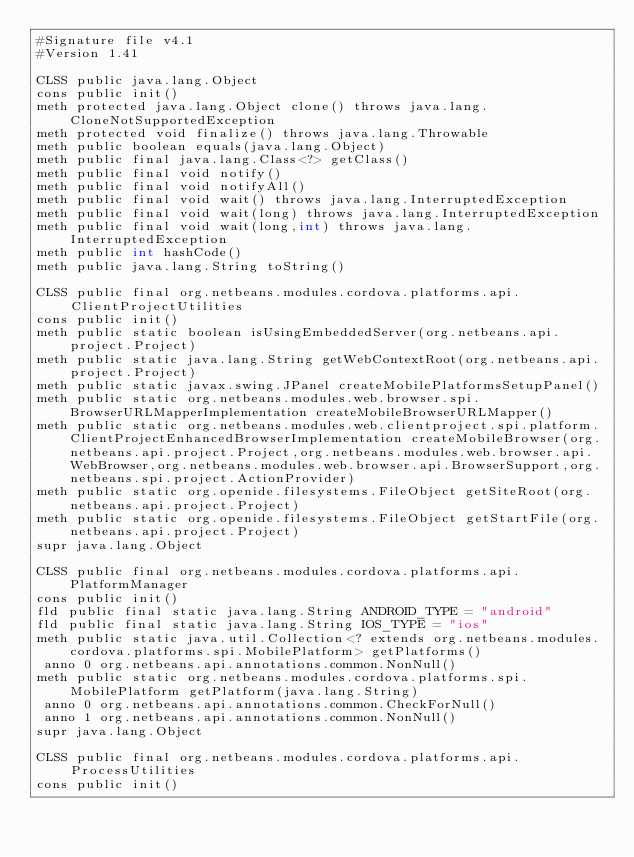Convert code to text. <code><loc_0><loc_0><loc_500><loc_500><_SML_>#Signature file v4.1
#Version 1.41

CLSS public java.lang.Object
cons public init()
meth protected java.lang.Object clone() throws java.lang.CloneNotSupportedException
meth protected void finalize() throws java.lang.Throwable
meth public boolean equals(java.lang.Object)
meth public final java.lang.Class<?> getClass()
meth public final void notify()
meth public final void notifyAll()
meth public final void wait() throws java.lang.InterruptedException
meth public final void wait(long) throws java.lang.InterruptedException
meth public final void wait(long,int) throws java.lang.InterruptedException
meth public int hashCode()
meth public java.lang.String toString()

CLSS public final org.netbeans.modules.cordova.platforms.api.ClientProjectUtilities
cons public init()
meth public static boolean isUsingEmbeddedServer(org.netbeans.api.project.Project)
meth public static java.lang.String getWebContextRoot(org.netbeans.api.project.Project)
meth public static javax.swing.JPanel createMobilePlatformsSetupPanel()
meth public static org.netbeans.modules.web.browser.spi.BrowserURLMapperImplementation createMobileBrowserURLMapper()
meth public static org.netbeans.modules.web.clientproject.spi.platform.ClientProjectEnhancedBrowserImplementation createMobileBrowser(org.netbeans.api.project.Project,org.netbeans.modules.web.browser.api.WebBrowser,org.netbeans.modules.web.browser.api.BrowserSupport,org.netbeans.spi.project.ActionProvider)
meth public static org.openide.filesystems.FileObject getSiteRoot(org.netbeans.api.project.Project)
meth public static org.openide.filesystems.FileObject getStartFile(org.netbeans.api.project.Project)
supr java.lang.Object

CLSS public final org.netbeans.modules.cordova.platforms.api.PlatformManager
cons public init()
fld public final static java.lang.String ANDROID_TYPE = "android"
fld public final static java.lang.String IOS_TYPE = "ios"
meth public static java.util.Collection<? extends org.netbeans.modules.cordova.platforms.spi.MobilePlatform> getPlatforms()
 anno 0 org.netbeans.api.annotations.common.NonNull()
meth public static org.netbeans.modules.cordova.platforms.spi.MobilePlatform getPlatform(java.lang.String)
 anno 0 org.netbeans.api.annotations.common.CheckForNull()
 anno 1 org.netbeans.api.annotations.common.NonNull()
supr java.lang.Object

CLSS public final org.netbeans.modules.cordova.platforms.api.ProcessUtilities
cons public init()</code> 